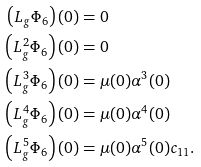<formula> <loc_0><loc_0><loc_500><loc_500>\left ( L _ { g } \Phi _ { 6 } \right ) ( 0 ) & = 0 \\ \left ( L _ { g } ^ { 2 } \Phi _ { 6 } \right ) ( 0 ) & = 0 \\ \left ( L _ { g } ^ { 3 } \Phi _ { 6 } \right ) ( 0 ) & = \mu ( 0 ) \alpha ^ { 3 } ( 0 ) \\ \left ( L _ { g } ^ { 4 } \Phi _ { 6 } \right ) ( 0 ) & = \mu ( 0 ) \alpha ^ { 4 } ( 0 ) \\ \left ( L _ { g } ^ { 5 } \Phi _ { 6 } \right ) ( 0 ) & = \mu ( 0 ) \alpha ^ { 5 } ( 0 ) c _ { 1 1 } .</formula> 